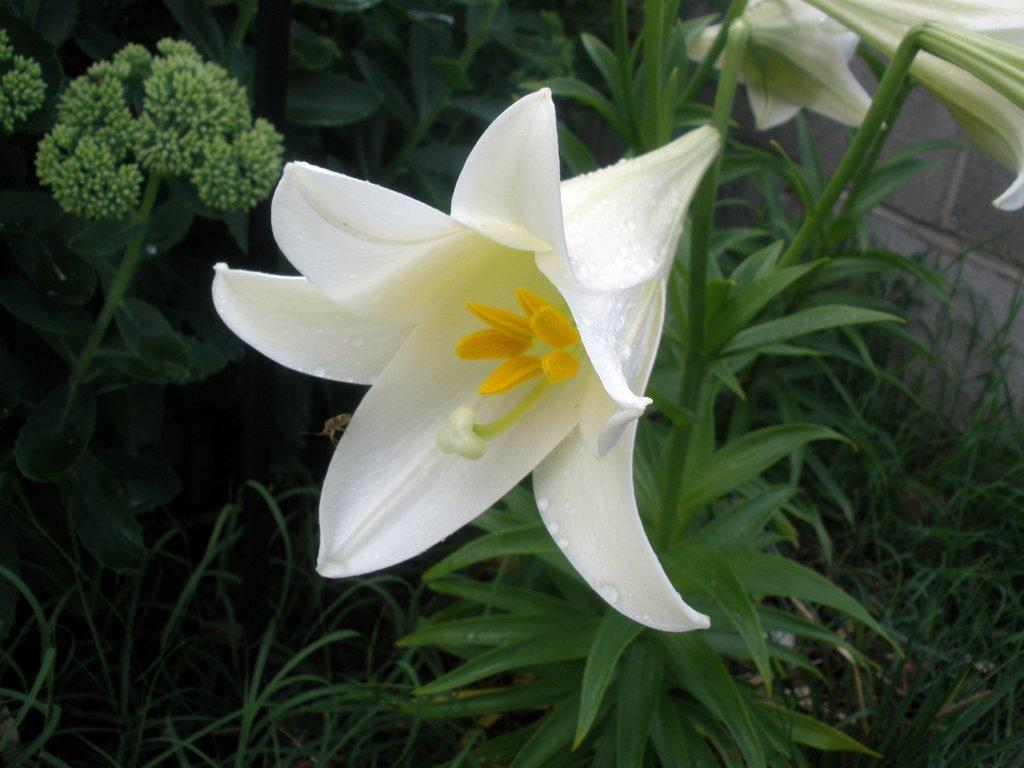What type of vegetation can be seen in the image? There are flowers, plants, and grass in the image. Can you describe the background of the image? There is a wall in the background of the image. What is the woman doing in the image? There is no woman present in the image. 